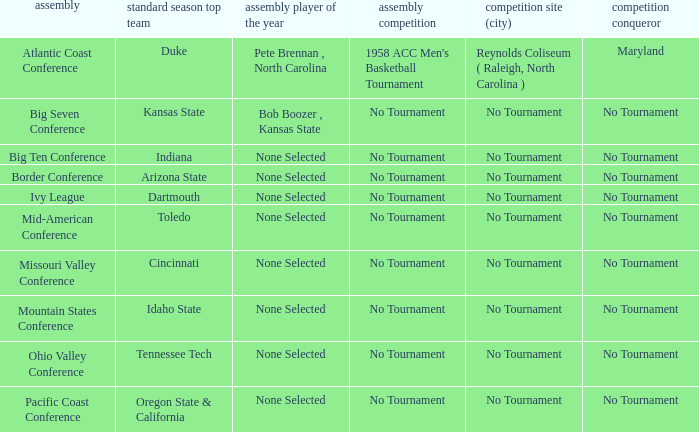I'm looking to parse the entire table for insights. Could you assist me with that? {'header': ['assembly', 'standard season top team', 'assembly player of the year', 'assembly competition', 'competition site (city)', 'competition conqueror'], 'rows': [['Atlantic Coast Conference', 'Duke', 'Pete Brennan , North Carolina', "1958 ACC Men's Basketball Tournament", 'Reynolds Coliseum ( Raleigh, North Carolina )', 'Maryland'], ['Big Seven Conference', 'Kansas State', 'Bob Boozer , Kansas State', 'No Tournament', 'No Tournament', 'No Tournament'], ['Big Ten Conference', 'Indiana', 'None Selected', 'No Tournament', 'No Tournament', 'No Tournament'], ['Border Conference', 'Arizona State', 'None Selected', 'No Tournament', 'No Tournament', 'No Tournament'], ['Ivy League', 'Dartmouth', 'None Selected', 'No Tournament', 'No Tournament', 'No Tournament'], ['Mid-American Conference', 'Toledo', 'None Selected', 'No Tournament', 'No Tournament', 'No Tournament'], ['Missouri Valley Conference', 'Cincinnati', 'None Selected', 'No Tournament', 'No Tournament', 'No Tournament'], ['Mountain States Conference', 'Idaho State', 'None Selected', 'No Tournament', 'No Tournament', 'No Tournament'], ['Ohio Valley Conference', 'Tennessee Tech', 'None Selected', 'No Tournament', 'No Tournament', 'No Tournament'], ['Pacific Coast Conference', 'Oregon State & California', 'None Selected', 'No Tournament', 'No Tournament', 'No Tournament']]} Who won the tournament when Idaho State won the regular season? No Tournament. 